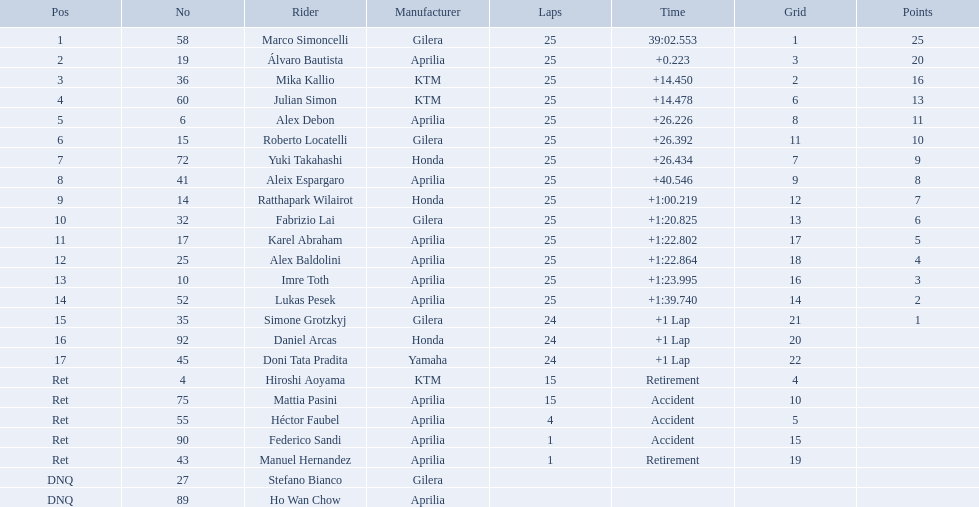How many laps did hiroshi aoyama perform? 15. How many laps did marco simoncelli perform? 25. Write the full table. {'header': ['Pos', 'No', 'Rider', 'Manufacturer', 'Laps', 'Time', 'Grid', 'Points'], 'rows': [['1', '58', 'Marco Simoncelli', 'Gilera', '25', '39:02.553', '1', '25'], ['2', '19', 'Álvaro Bautista', 'Aprilia', '25', '+0.223', '3', '20'], ['3', '36', 'Mika Kallio', 'KTM', '25', '+14.450', '2', '16'], ['4', '60', 'Julian Simon', 'KTM', '25', '+14.478', '6', '13'], ['5', '6', 'Alex Debon', 'Aprilia', '25', '+26.226', '8', '11'], ['6', '15', 'Roberto Locatelli', 'Gilera', '25', '+26.392', '11', '10'], ['7', '72', 'Yuki Takahashi', 'Honda', '25', '+26.434', '7', '9'], ['8', '41', 'Aleix Espargaro', 'Aprilia', '25', '+40.546', '9', '8'], ['9', '14', 'Ratthapark Wilairot', 'Honda', '25', '+1:00.219', '12', '7'], ['10', '32', 'Fabrizio Lai', 'Gilera', '25', '+1:20.825', '13', '6'], ['11', '17', 'Karel Abraham', 'Aprilia', '25', '+1:22.802', '17', '5'], ['12', '25', 'Alex Baldolini', 'Aprilia', '25', '+1:22.864', '18', '4'], ['13', '10', 'Imre Toth', 'Aprilia', '25', '+1:23.995', '16', '3'], ['14', '52', 'Lukas Pesek', 'Aprilia', '25', '+1:39.740', '14', '2'], ['15', '35', 'Simone Grotzkyj', 'Gilera', '24', '+1 Lap', '21', '1'], ['16', '92', 'Daniel Arcas', 'Honda', '24', '+1 Lap', '20', ''], ['17', '45', 'Doni Tata Pradita', 'Yamaha', '24', '+1 Lap', '22', ''], ['Ret', '4', 'Hiroshi Aoyama', 'KTM', '15', 'Retirement', '4', ''], ['Ret', '75', 'Mattia Pasini', 'Aprilia', '15', 'Accident', '10', ''], ['Ret', '55', 'Héctor Faubel', 'Aprilia', '4', 'Accident', '5', ''], ['Ret', '90', 'Federico Sandi', 'Aprilia', '1', 'Accident', '15', ''], ['Ret', '43', 'Manuel Hernandez', 'Aprilia', '1', 'Retirement', '19', ''], ['DNQ', '27', 'Stefano Bianco', 'Gilera', '', '', '', ''], ['DNQ', '89', 'Ho Wan Chow', 'Aprilia', '', '', '', '']]} Who performed more laps out of hiroshi aoyama and marco 
simoncelli? Marco Simoncelli. Which contestant number is assigned #1 for the australian motorcycle grand prix? 58. Who is the rider that stands for the #58 in the australian motorcycle grand prix? Marco Simoncelli. What competitor number is designated #1 for the australian motorcycle grand prix? 58. Who is the motorcyclist that symbolizes the #58 in the australian motorcycle grand prix? Marco Simoncelli. What was the number of laps completed by hiroshi aoyama? 15. How many laps did marco simoncelli complete? 25. Which of the two, hiroshi aoyama or marco simoncelli, finished more laps? Marco Simoncelli. Who were the participants in the race? Marco Simoncelli, Álvaro Bautista, Mika Kallio, Julian Simon, Alex Debon, Roberto Locatelli, Yuki Takahashi, Aleix Espargaro, Ratthapark Wilairot, Fabrizio Lai, Karel Abraham, Alex Baldolini, Imre Toth, Lukas Pesek, Simone Grotzkyj, Daniel Arcas, Doni Tata Pradita, Hiroshi Aoyama, Mattia Pasini, Héctor Faubel, Federico Sandi, Manuel Hernandez, Stefano Bianco, Ho Wan Chow. What was their lap count? 25, 25, 25, 25, 25, 25, 25, 25, 25, 25, 25, 25, 25, 25, 24, 24, 24, 15, 15, 4, 1, 1, , . Which of marco simoncelli or hiroshi aoyama completed more laps? Marco Simoncelli. 